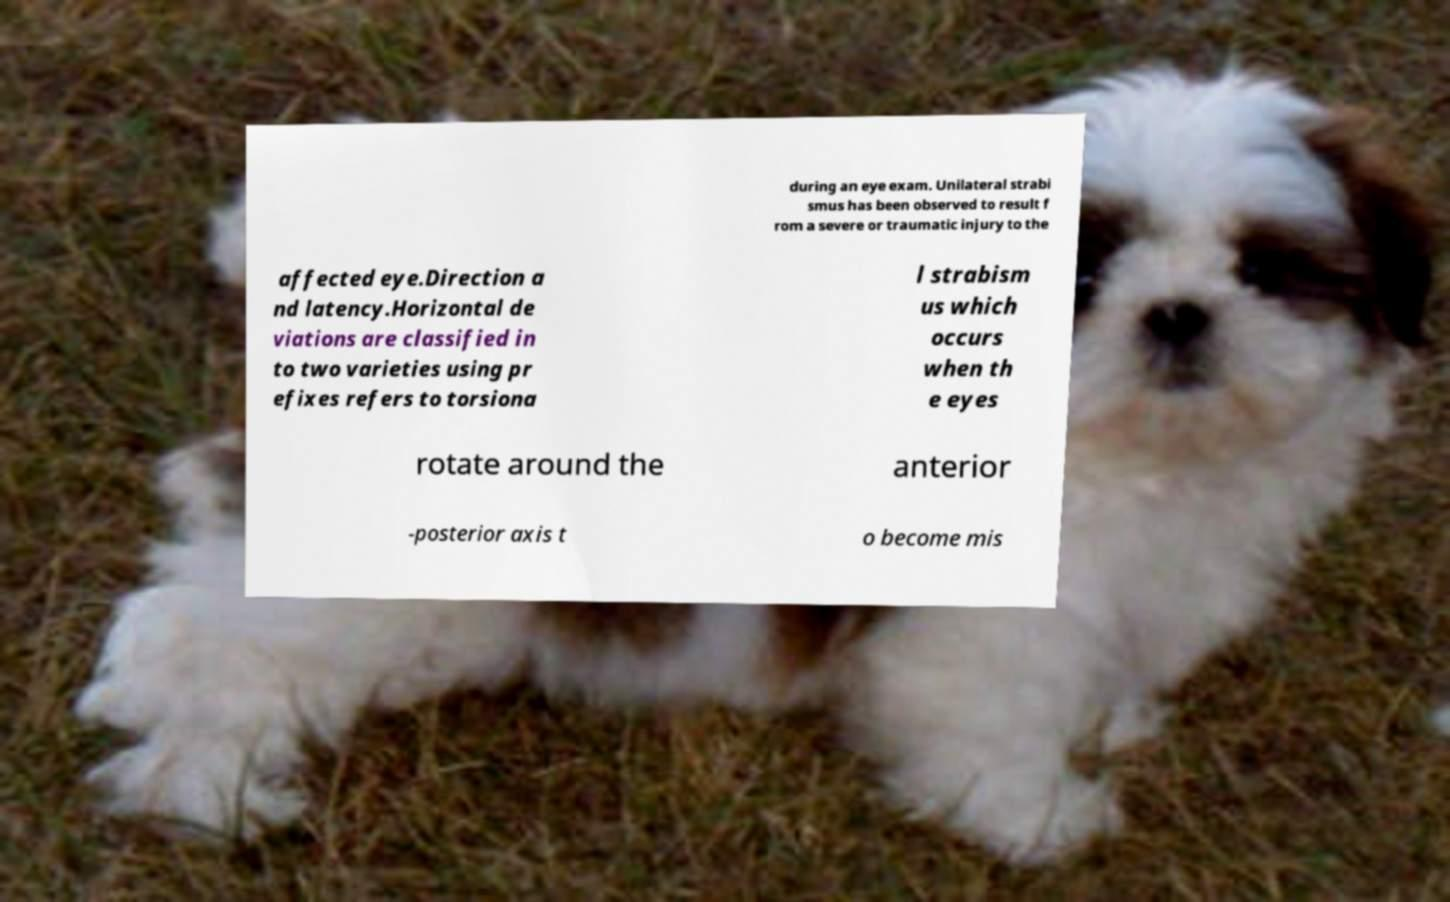Can you read and provide the text displayed in the image?This photo seems to have some interesting text. Can you extract and type it out for me? during an eye exam. Unilateral strabi smus has been observed to result f rom a severe or traumatic injury to the affected eye.Direction a nd latency.Horizontal de viations are classified in to two varieties using pr efixes refers to torsiona l strabism us which occurs when th e eyes rotate around the anterior -posterior axis t o become mis 